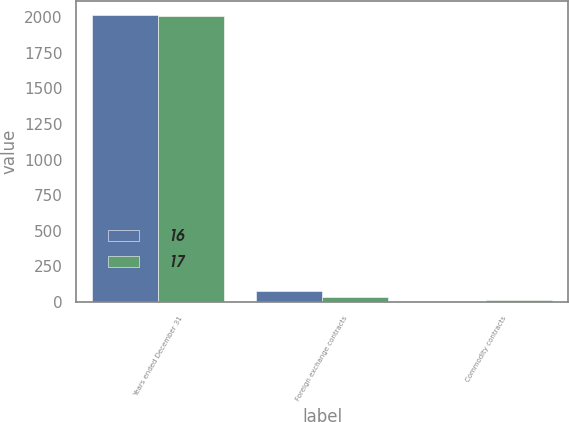Convert chart to OTSL. <chart><loc_0><loc_0><loc_500><loc_500><stacked_bar_chart><ecel><fcel>Years ended December 31<fcel>Foreign exchange contracts<fcel>Commodity contracts<nl><fcel>16<fcel>2013<fcel>76<fcel>1<nl><fcel>17<fcel>2012<fcel>35<fcel>10<nl></chart> 